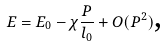<formula> <loc_0><loc_0><loc_500><loc_500>E = E _ { 0 } - \chi \frac { P } { l _ { 0 } } + O ( P ^ { 2 } ) \text {,}</formula> 